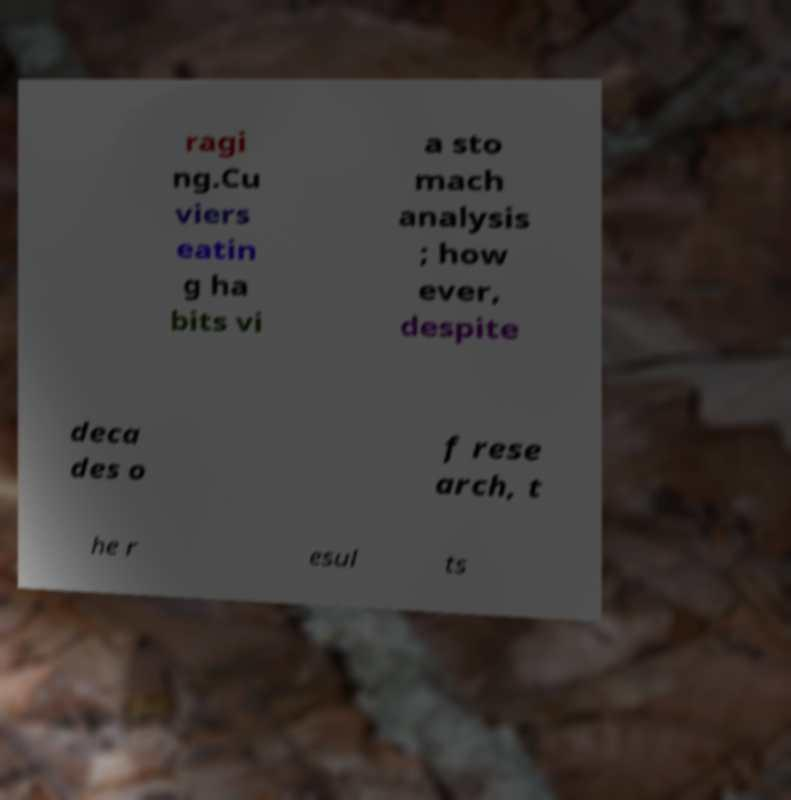What messages or text are displayed in this image? I need them in a readable, typed format. ragi ng.Cu viers eatin g ha bits vi a sto mach analysis ; how ever, despite deca des o f rese arch, t he r esul ts 